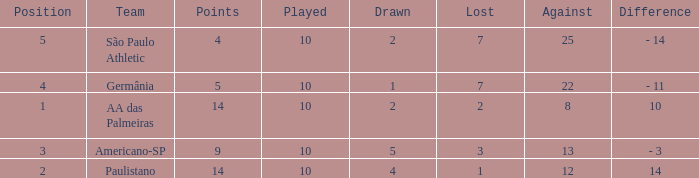What is the highest Drawn when the lost is 7 and the points are more than 4, and the against is less than 22? None. 